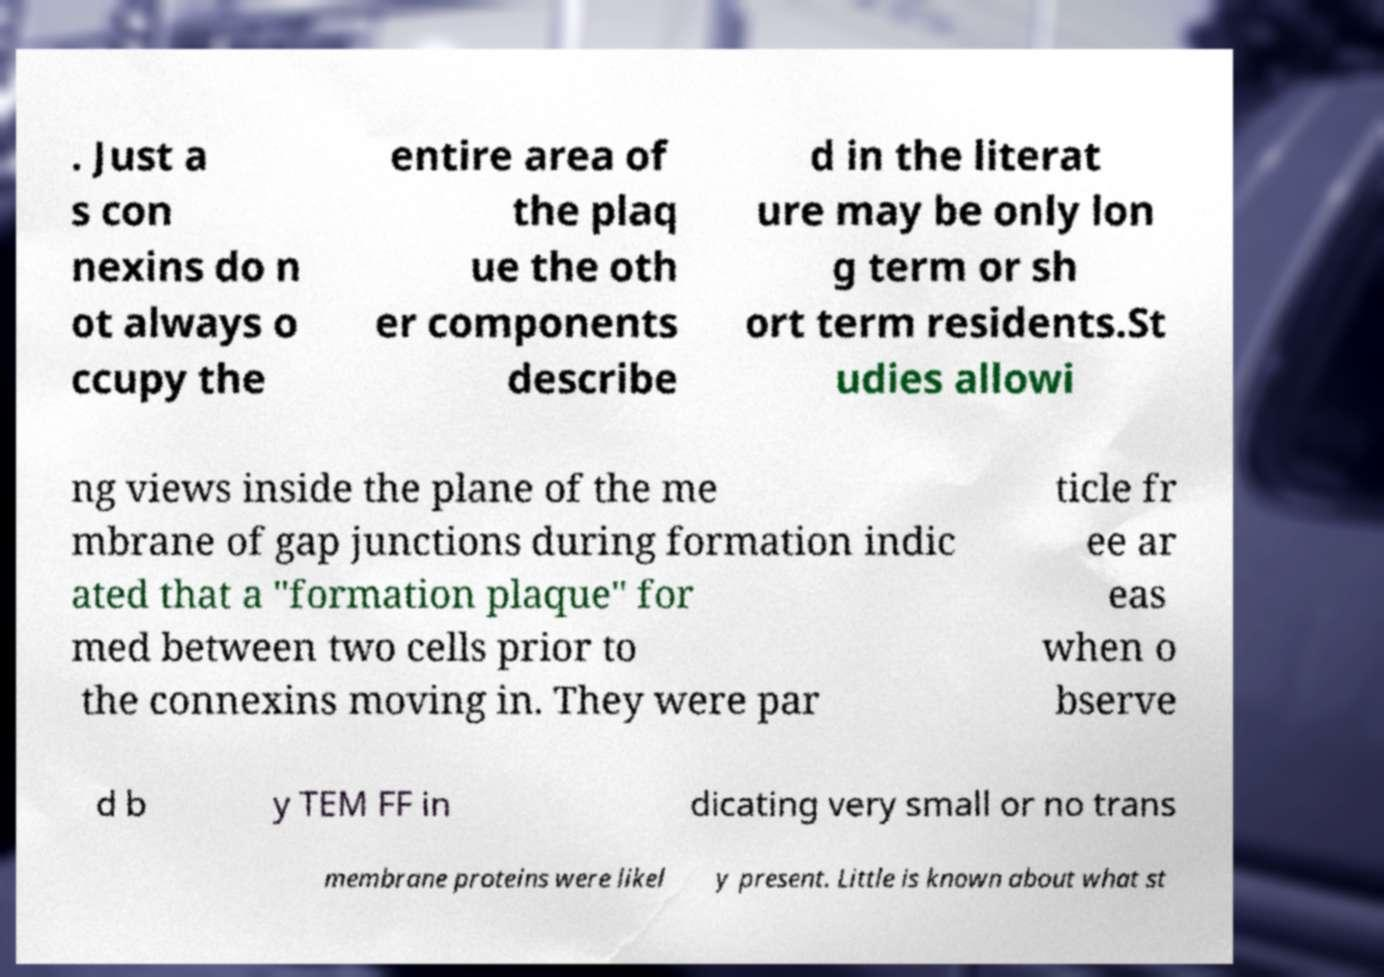What messages or text are displayed in this image? I need them in a readable, typed format. . Just a s con nexins do n ot always o ccupy the entire area of the plaq ue the oth er components describe d in the literat ure may be only lon g term or sh ort term residents.St udies allowi ng views inside the plane of the me mbrane of gap junctions during formation indic ated that a "formation plaque" for med between two cells prior to the connexins moving in. They were par ticle fr ee ar eas when o bserve d b y TEM FF in dicating very small or no trans membrane proteins were likel y present. Little is known about what st 